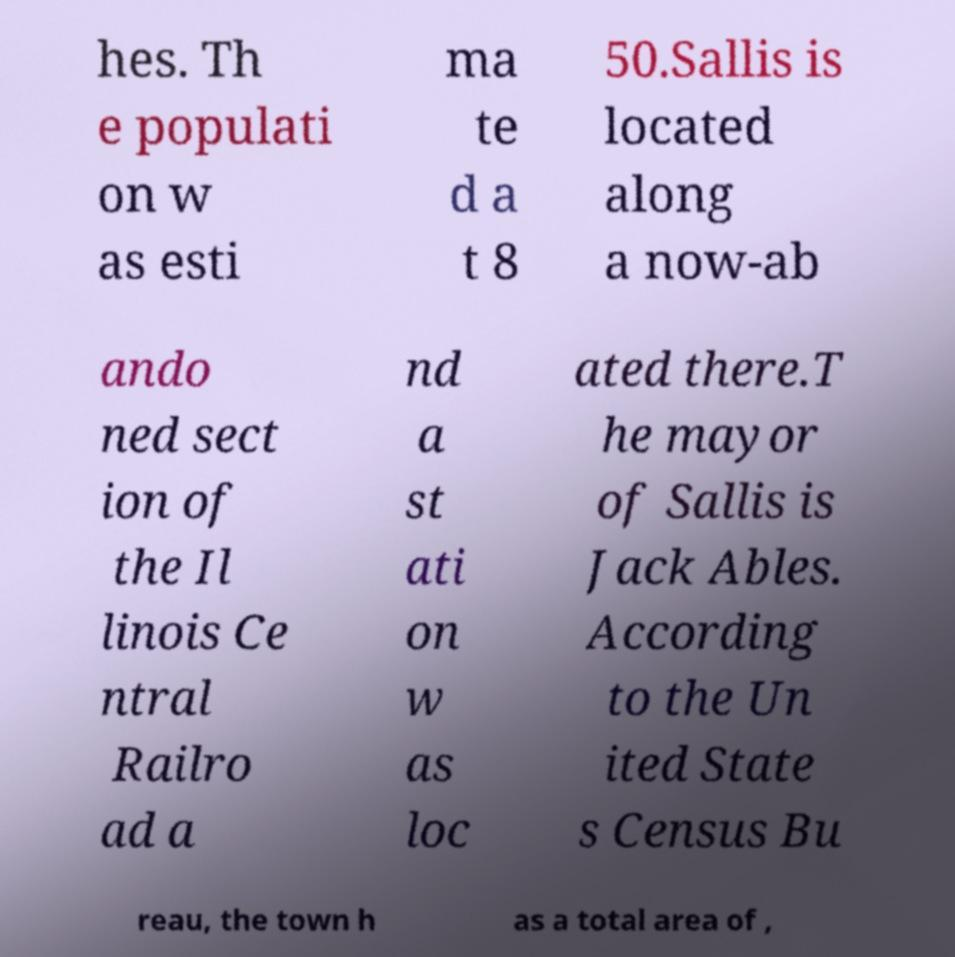Can you accurately transcribe the text from the provided image for me? hes. Th e populati on w as esti ma te d a t 8 50.Sallis is located along a now-ab ando ned sect ion of the Il linois Ce ntral Railro ad a nd a st ati on w as loc ated there.T he mayor of Sallis is Jack Ables. According to the Un ited State s Census Bu reau, the town h as a total area of , 